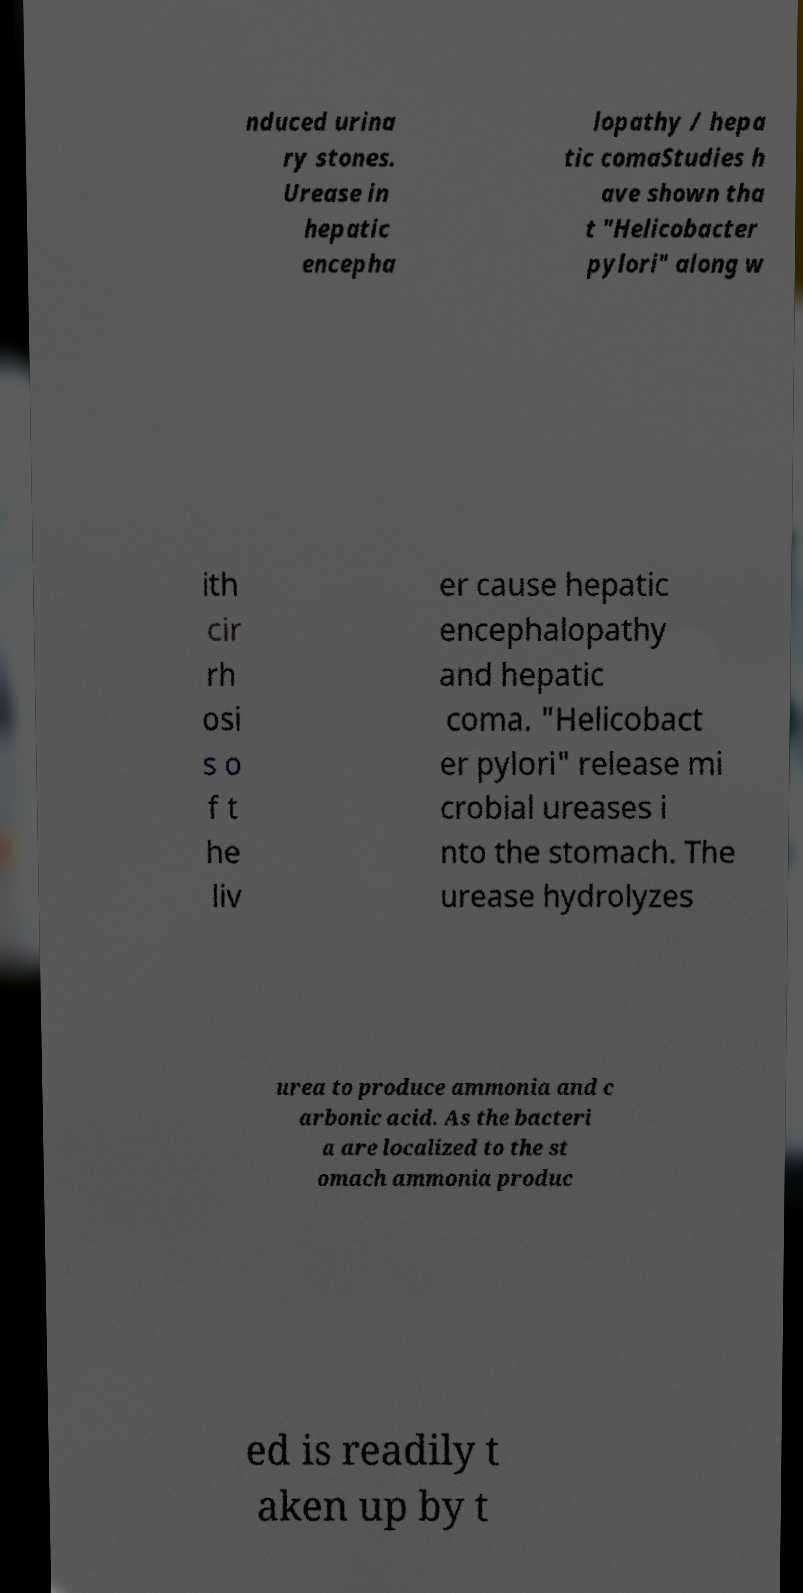Can you read and provide the text displayed in the image?This photo seems to have some interesting text. Can you extract and type it out for me? nduced urina ry stones. Urease in hepatic encepha lopathy / hepa tic comaStudies h ave shown tha t "Helicobacter pylori" along w ith cir rh osi s o f t he liv er cause hepatic encephalopathy and hepatic coma. "Helicobact er pylori" release mi crobial ureases i nto the stomach. The urease hydrolyzes urea to produce ammonia and c arbonic acid. As the bacteri a are localized to the st omach ammonia produc ed is readily t aken up by t 